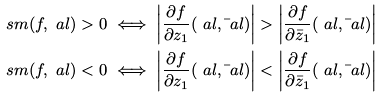<formula> <loc_0><loc_0><loc_500><loc_500>& \ s m ( f , \ a l ) > 0 \iff \left | \frac { \partial f } { \partial z _ { 1 } } ( \ a l , \bar { \ } a l ) \right | > \left | \frac { \partial f } { \partial \bar { z } _ { 1 } } ( \ a l , \bar { \ } a l ) \right | \\ & \ s m ( f , \ a l ) < 0 \iff \left | \frac { \partial f } { \partial z _ { 1 } } ( \ a l , \bar { \ } a l ) \right | < \left | \frac { \partial f } { \partial \bar { z } _ { 1 } } ( \ a l , \bar { \ } a l ) \right |</formula> 